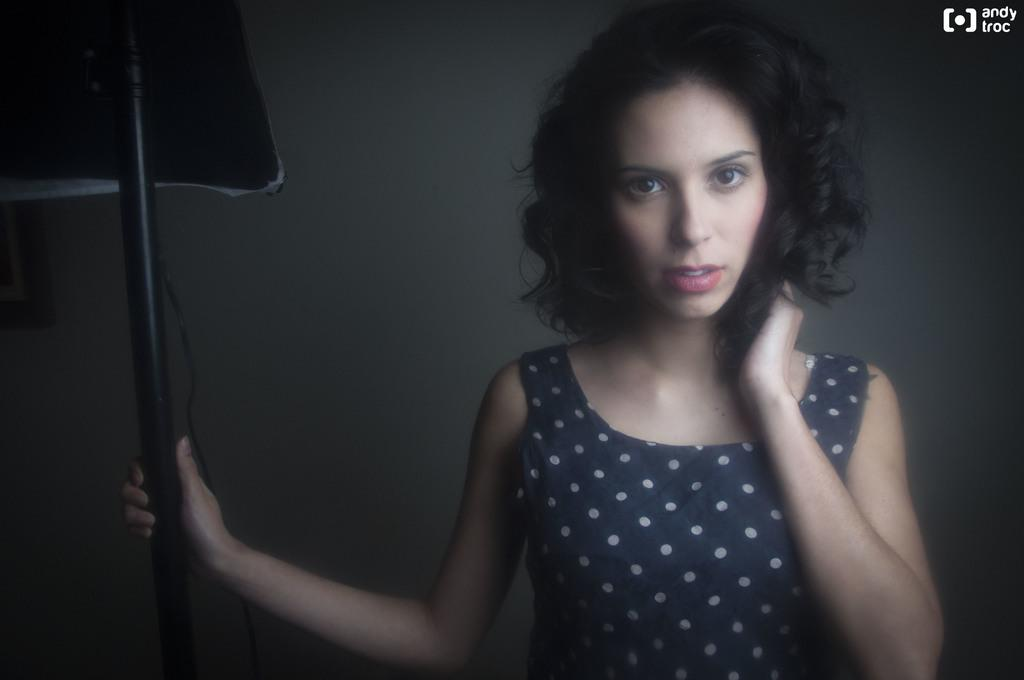What is the main subject of the image? There is a person in the image. What is the person holding in the image? The person is holding a pole. What can be seen in the background of the image? There is a wall in the background of the image. Where is the text located in the image? The text is on the top right side of the image. What type of volleyball game is being played in the image? There is no volleyball game present in the image. Can you tell me how many bells are hanging from the pole in the image? There are no bells hanging from the pole in the image; the person is simply holding a pole. 